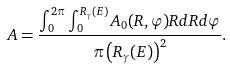<formula> <loc_0><loc_0><loc_500><loc_500>A = \frac { \int _ { 0 } ^ { 2 \pi } \int _ { 0 } ^ { R _ { \gamma } ( E ) } A _ { 0 } ( R , \varphi ) R d R d \varphi } { \pi \left ( R _ { \gamma } ( E ) \right ) ^ { 2 } } .</formula> 